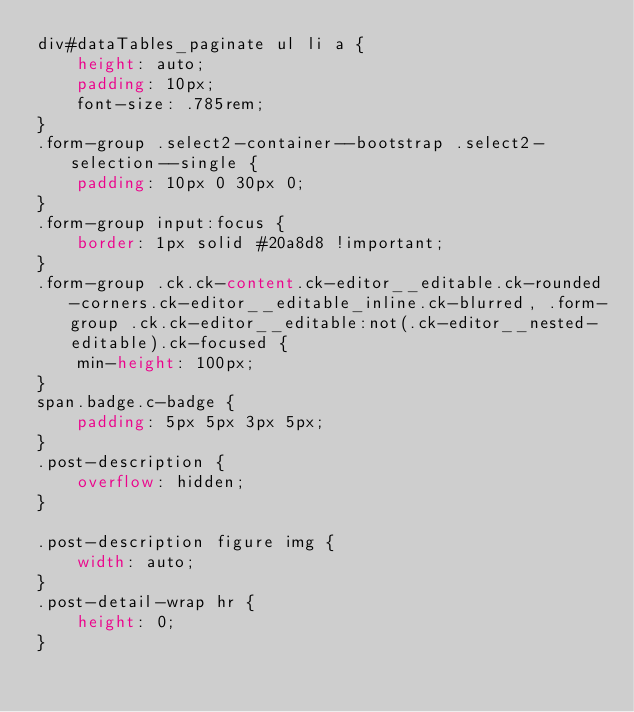Convert code to text. <code><loc_0><loc_0><loc_500><loc_500><_CSS_>div#dataTables_paginate ul li a {
    height: auto;
    padding: 10px;
    font-size: .785rem;
}
.form-group .select2-container--bootstrap .select2-selection--single {
    padding: 10px 0 30px 0;
}
.form-group input:focus {
    border: 1px solid #20a8d8 !important;
}
.form-group .ck.ck-content.ck-editor__editable.ck-rounded-corners.ck-editor__editable_inline.ck-blurred, .form-group .ck.ck-editor__editable:not(.ck-editor__nested-editable).ck-focused {
    min-height: 100px;
}
span.badge.c-badge {
    padding: 5px 5px 3px 5px;
}
.post-description {
    overflow: hidden;
}

.post-description figure img {
    width: auto;
}
.post-detail-wrap hr {
    height: 0;
}</code> 